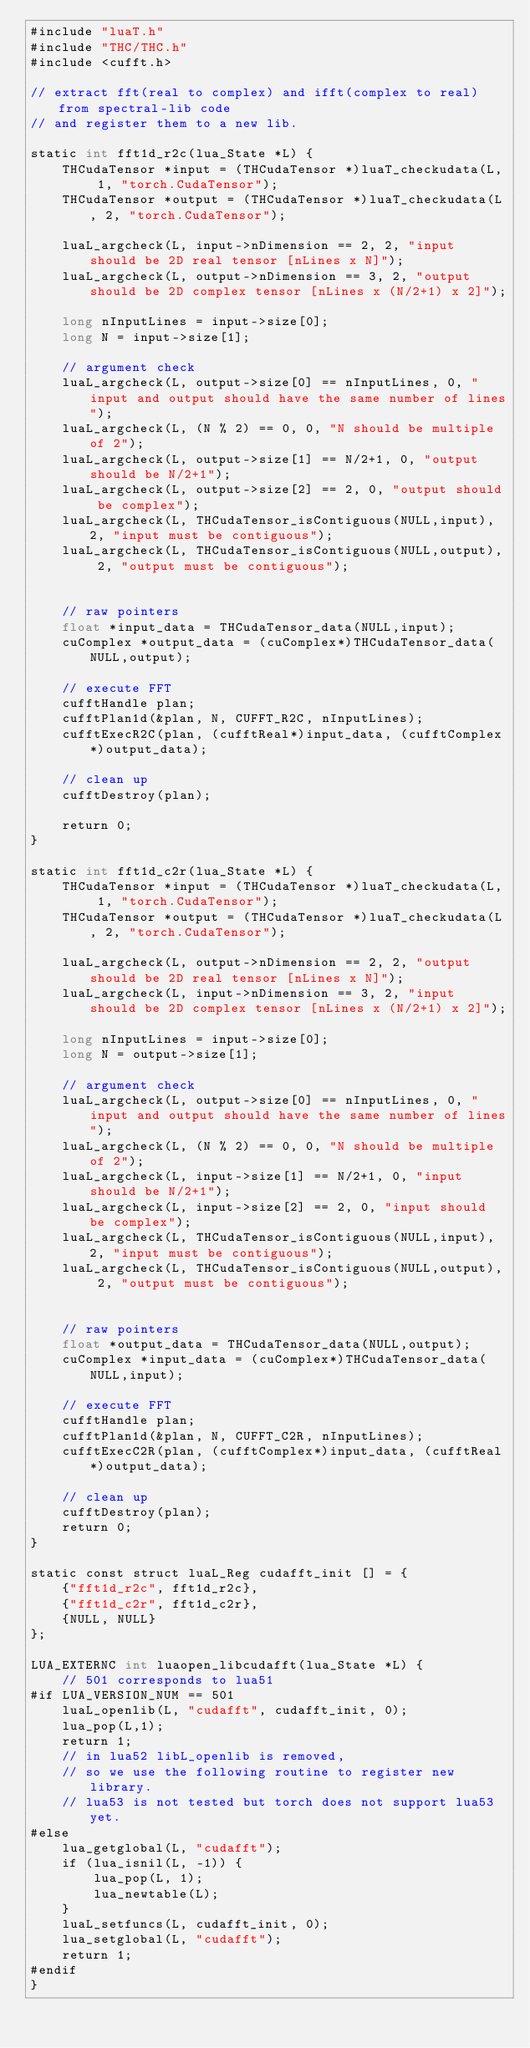<code> <loc_0><loc_0><loc_500><loc_500><_Cuda_>#include "luaT.h"
#include "THC/THC.h"
#include <cufft.h>

// extract fft(real to complex) and ifft(complex to real) from spectral-lib code 
// and register them to a new lib.

static int fft1d_r2c(lua_State *L) {
    THCudaTensor *input = (THCudaTensor *)luaT_checkudata(L, 1, "torch.CudaTensor");
    THCudaTensor *output = (THCudaTensor *)luaT_checkudata(L, 2, "torch.CudaTensor");

    luaL_argcheck(L, input->nDimension == 2, 2, "input should be 2D real tensor [nLines x N]");
    luaL_argcheck(L, output->nDimension == 3, 2, "output should be 2D complex tensor [nLines x (N/2+1) x 2]");
    
    long nInputLines = input->size[0];
    long N = input->size[1];

    // argument check
    luaL_argcheck(L, output->size[0] == nInputLines, 0, "input and output should have the same number of lines");
    luaL_argcheck(L, (N % 2) == 0, 0, "N should be multiple of 2");
    luaL_argcheck(L, output->size[1] == N/2+1, 0, "output should be N/2+1");
    luaL_argcheck(L, output->size[2] == 2, 0, "output should be complex");
    luaL_argcheck(L, THCudaTensor_isContiguous(NULL,input), 2, "input must be contiguous");
    luaL_argcheck(L, THCudaTensor_isContiguous(NULL,output), 2, "output must be contiguous");
    

    // raw pointers 
    float *input_data = THCudaTensor_data(NULL,input);
    cuComplex *output_data = (cuComplex*)THCudaTensor_data(NULL,output);
    
    // execute FFT
    cufftHandle plan;
    cufftPlan1d(&plan, N, CUFFT_R2C, nInputLines);
    cufftExecR2C(plan, (cufftReal*)input_data, (cufftComplex*)output_data);

    // clean up
    cufftDestroy(plan);

    return 0;
}

static int fft1d_c2r(lua_State *L) {
	THCudaTensor *input = (THCudaTensor *)luaT_checkudata(L, 1, "torch.CudaTensor");	
	THCudaTensor *output = (THCudaTensor *)luaT_checkudata(L, 2, "torch.CudaTensor");

	luaL_argcheck(L, output->nDimension == 2, 2, "output should be 2D real tensor [nLines x N]");
   	luaL_argcheck(L, input->nDimension == 3, 2, "input should be 2D complex tensor [nLines x (N/2+1) x 2]");
	
	long nInputLines = input->size[0];
	long N = output->size[1];

	// argument check
	luaL_argcheck(L, output->size[0] == nInputLines, 0, "input and output should have the same number of lines");
	luaL_argcheck(L, (N % 2) == 0, 0, "N should be multiple of 2");
	luaL_argcheck(L, input->size[1] == N/2+1, 0, "input should be N/2+1");
	luaL_argcheck(L, input->size[2] == 2, 0, "input should be complex");
	luaL_argcheck(L, THCudaTensor_isContiguous(NULL,input), 2, "input must be contiguous");
	luaL_argcheck(L, THCudaTensor_isContiguous(NULL,output), 2, "output must be contiguous");
	

	// raw pointers 
	float *output_data = THCudaTensor_data(NULL,output);
	cuComplex *input_data = (cuComplex*)THCudaTensor_data(NULL,input);
	
	// execute FFT
	cufftHandle plan;
	cufftPlan1d(&plan, N, CUFFT_C2R, nInputLines);
	cufftExecC2R(plan, (cufftComplex*)input_data, (cufftReal*)output_data);

	// clean up
	cufftDestroy(plan);
	return 0;	
}

static const struct luaL_Reg cudafft_init [] = {
    {"fft1d_r2c", fft1d_r2c},
    {"fft1d_c2r", fft1d_c2r},
    {NULL, NULL}
};

LUA_EXTERNC int luaopen_libcudafft(lua_State *L) {
    // 501 corresponds to lua51
#if LUA_VERSION_NUM == 501
    luaL_openlib(L, "cudafft", cudafft_init, 0);
    lua_pop(L,1);
    return 1;
    // in lua52 libL_openlib is removed,
    // so we use the following routine to register new library.
    // lua53 is not tested but torch does not support lua53 yet.
#else
    lua_getglobal(L, "cudafft");
    if (lua_isnil(L, -1)) {
        lua_pop(L, 1);
        lua_newtable(L);
    }
    luaL_setfuncs(L, cudafft_init, 0);
    lua_setglobal(L, "cudafft");
    return 1;
#endif
}
</code> 